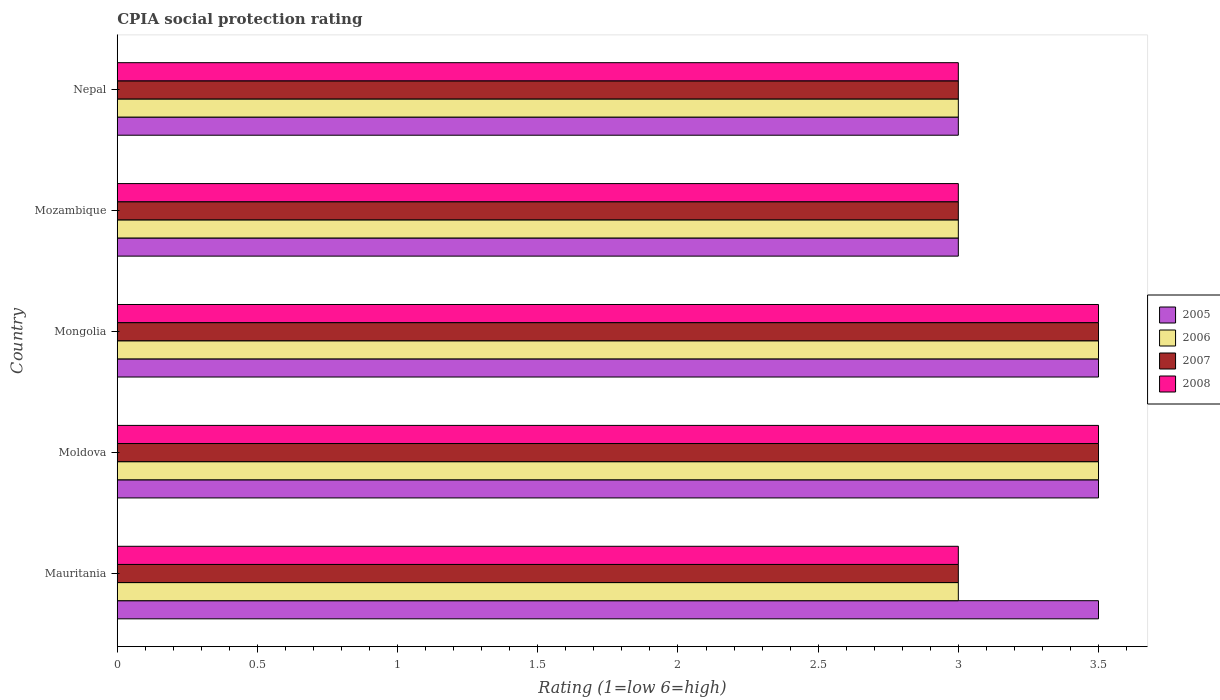How many groups of bars are there?
Your answer should be compact. 5. Are the number of bars on each tick of the Y-axis equal?
Your answer should be compact. Yes. What is the label of the 2nd group of bars from the top?
Your response must be concise. Mozambique. In how many cases, is the number of bars for a given country not equal to the number of legend labels?
Keep it short and to the point. 0. What is the CPIA rating in 2007 in Nepal?
Give a very brief answer. 3. Across all countries, what is the maximum CPIA rating in 2006?
Your answer should be very brief. 3.5. In which country was the CPIA rating in 2007 maximum?
Offer a terse response. Moldova. In which country was the CPIA rating in 2008 minimum?
Provide a short and direct response. Mauritania. What is the total CPIA rating in 2008 in the graph?
Your answer should be very brief. 16. What is the difference between the CPIA rating in 2007 in Mozambique and the CPIA rating in 2005 in Moldova?
Your answer should be very brief. -0.5. What is the difference between the CPIA rating in 2006 and CPIA rating in 2005 in Nepal?
Provide a short and direct response. 0. In how many countries, is the CPIA rating in 2008 greater than 1.5 ?
Keep it short and to the point. 5. What is the ratio of the CPIA rating in 2008 in Moldova to that in Mozambique?
Ensure brevity in your answer.  1.17. What is the difference between the highest and the second highest CPIA rating in 2005?
Your answer should be compact. 0. In how many countries, is the CPIA rating in 2006 greater than the average CPIA rating in 2006 taken over all countries?
Your answer should be very brief. 2. Is it the case that in every country, the sum of the CPIA rating in 2007 and CPIA rating in 2008 is greater than the sum of CPIA rating in 2006 and CPIA rating in 2005?
Offer a very short reply. No. What does the 1st bar from the top in Mauritania represents?
Offer a very short reply. 2008. How many countries are there in the graph?
Your response must be concise. 5. Does the graph contain any zero values?
Provide a short and direct response. No. How many legend labels are there?
Provide a succinct answer. 4. What is the title of the graph?
Your answer should be compact. CPIA social protection rating. Does "1982" appear as one of the legend labels in the graph?
Offer a very short reply. No. What is the label or title of the X-axis?
Your response must be concise. Rating (1=low 6=high). What is the label or title of the Y-axis?
Make the answer very short. Country. What is the Rating (1=low 6=high) of 2006 in Mauritania?
Your answer should be very brief. 3. What is the Rating (1=low 6=high) in 2008 in Mauritania?
Your response must be concise. 3. What is the Rating (1=low 6=high) in 2005 in Moldova?
Keep it short and to the point. 3.5. What is the Rating (1=low 6=high) of 2007 in Moldova?
Your response must be concise. 3.5. What is the Rating (1=low 6=high) in 2006 in Mongolia?
Provide a short and direct response. 3.5. What is the Rating (1=low 6=high) of 2007 in Mozambique?
Provide a short and direct response. 3. What is the Rating (1=low 6=high) in 2005 in Nepal?
Ensure brevity in your answer.  3. What is the Rating (1=low 6=high) of 2006 in Nepal?
Your response must be concise. 3. Across all countries, what is the maximum Rating (1=low 6=high) in 2006?
Your response must be concise. 3.5. Across all countries, what is the maximum Rating (1=low 6=high) of 2007?
Keep it short and to the point. 3.5. Across all countries, what is the maximum Rating (1=low 6=high) in 2008?
Ensure brevity in your answer.  3.5. Across all countries, what is the minimum Rating (1=low 6=high) in 2005?
Your response must be concise. 3. Across all countries, what is the minimum Rating (1=low 6=high) of 2007?
Offer a terse response. 3. Across all countries, what is the minimum Rating (1=low 6=high) of 2008?
Your answer should be compact. 3. What is the total Rating (1=low 6=high) in 2006 in the graph?
Provide a succinct answer. 16. What is the total Rating (1=low 6=high) in 2007 in the graph?
Your response must be concise. 16. What is the total Rating (1=low 6=high) in 2008 in the graph?
Provide a short and direct response. 16. What is the difference between the Rating (1=low 6=high) in 2006 in Mauritania and that in Moldova?
Offer a very short reply. -0.5. What is the difference between the Rating (1=low 6=high) of 2007 in Mauritania and that in Moldova?
Give a very brief answer. -0.5. What is the difference between the Rating (1=low 6=high) of 2006 in Mauritania and that in Mongolia?
Ensure brevity in your answer.  -0.5. What is the difference between the Rating (1=low 6=high) of 2007 in Mauritania and that in Mongolia?
Your answer should be compact. -0.5. What is the difference between the Rating (1=low 6=high) of 2008 in Mauritania and that in Mongolia?
Your answer should be very brief. -0.5. What is the difference between the Rating (1=low 6=high) of 2007 in Mauritania and that in Mozambique?
Offer a terse response. 0. What is the difference between the Rating (1=low 6=high) in 2008 in Mauritania and that in Mozambique?
Offer a very short reply. 0. What is the difference between the Rating (1=low 6=high) in 2007 in Mauritania and that in Nepal?
Your answer should be compact. 0. What is the difference between the Rating (1=low 6=high) in 2007 in Moldova and that in Mongolia?
Provide a short and direct response. 0. What is the difference between the Rating (1=low 6=high) in 2008 in Moldova and that in Mongolia?
Give a very brief answer. 0. What is the difference between the Rating (1=low 6=high) in 2005 in Moldova and that in Mozambique?
Offer a very short reply. 0.5. What is the difference between the Rating (1=low 6=high) of 2006 in Moldova and that in Mozambique?
Ensure brevity in your answer.  0.5. What is the difference between the Rating (1=low 6=high) in 2008 in Moldova and that in Mozambique?
Keep it short and to the point. 0.5. What is the difference between the Rating (1=low 6=high) in 2006 in Moldova and that in Nepal?
Ensure brevity in your answer.  0.5. What is the difference between the Rating (1=low 6=high) of 2008 in Moldova and that in Nepal?
Offer a terse response. 0.5. What is the difference between the Rating (1=low 6=high) of 2006 in Mongolia and that in Mozambique?
Provide a short and direct response. 0.5. What is the difference between the Rating (1=low 6=high) of 2006 in Mongolia and that in Nepal?
Give a very brief answer. 0.5. What is the difference between the Rating (1=low 6=high) of 2008 in Mozambique and that in Nepal?
Provide a short and direct response. 0. What is the difference between the Rating (1=low 6=high) of 2005 in Mauritania and the Rating (1=low 6=high) of 2007 in Moldova?
Provide a short and direct response. 0. What is the difference between the Rating (1=low 6=high) in 2005 in Mauritania and the Rating (1=low 6=high) in 2008 in Moldova?
Give a very brief answer. 0. What is the difference between the Rating (1=low 6=high) of 2006 in Mauritania and the Rating (1=low 6=high) of 2008 in Moldova?
Provide a short and direct response. -0.5. What is the difference between the Rating (1=low 6=high) of 2007 in Mauritania and the Rating (1=low 6=high) of 2008 in Moldova?
Keep it short and to the point. -0.5. What is the difference between the Rating (1=low 6=high) of 2005 in Mauritania and the Rating (1=low 6=high) of 2008 in Mongolia?
Offer a very short reply. 0. What is the difference between the Rating (1=low 6=high) of 2006 in Mauritania and the Rating (1=low 6=high) of 2007 in Mongolia?
Give a very brief answer. -0.5. What is the difference between the Rating (1=low 6=high) of 2007 in Mauritania and the Rating (1=low 6=high) of 2008 in Mongolia?
Offer a terse response. -0.5. What is the difference between the Rating (1=low 6=high) in 2005 in Mauritania and the Rating (1=low 6=high) in 2006 in Mozambique?
Offer a very short reply. 0.5. What is the difference between the Rating (1=low 6=high) of 2005 in Mauritania and the Rating (1=low 6=high) of 2006 in Nepal?
Offer a very short reply. 0.5. What is the difference between the Rating (1=low 6=high) in 2005 in Mauritania and the Rating (1=low 6=high) in 2008 in Nepal?
Ensure brevity in your answer.  0.5. What is the difference between the Rating (1=low 6=high) of 2007 in Mauritania and the Rating (1=low 6=high) of 2008 in Nepal?
Give a very brief answer. 0. What is the difference between the Rating (1=low 6=high) of 2005 in Moldova and the Rating (1=low 6=high) of 2008 in Mozambique?
Ensure brevity in your answer.  0.5. What is the difference between the Rating (1=low 6=high) of 2006 in Moldova and the Rating (1=low 6=high) of 2008 in Mozambique?
Ensure brevity in your answer.  0.5. What is the difference between the Rating (1=low 6=high) of 2005 in Moldova and the Rating (1=low 6=high) of 2007 in Nepal?
Ensure brevity in your answer.  0.5. What is the difference between the Rating (1=low 6=high) in 2006 in Moldova and the Rating (1=low 6=high) in 2007 in Nepal?
Your answer should be very brief. 0.5. What is the difference between the Rating (1=low 6=high) in 2006 in Moldova and the Rating (1=low 6=high) in 2008 in Nepal?
Provide a short and direct response. 0.5. What is the difference between the Rating (1=low 6=high) in 2007 in Moldova and the Rating (1=low 6=high) in 2008 in Nepal?
Give a very brief answer. 0.5. What is the difference between the Rating (1=low 6=high) in 2005 in Mongolia and the Rating (1=low 6=high) in 2006 in Mozambique?
Keep it short and to the point. 0.5. What is the difference between the Rating (1=low 6=high) of 2005 in Mongolia and the Rating (1=low 6=high) of 2007 in Mozambique?
Keep it short and to the point. 0.5. What is the difference between the Rating (1=low 6=high) in 2005 in Mongolia and the Rating (1=low 6=high) in 2006 in Nepal?
Provide a short and direct response. 0.5. What is the difference between the Rating (1=low 6=high) of 2005 in Mongolia and the Rating (1=low 6=high) of 2007 in Nepal?
Make the answer very short. 0.5. What is the difference between the Rating (1=low 6=high) in 2005 in Mongolia and the Rating (1=low 6=high) in 2008 in Nepal?
Offer a very short reply. 0.5. What is the difference between the Rating (1=low 6=high) of 2006 in Mongolia and the Rating (1=low 6=high) of 2007 in Nepal?
Give a very brief answer. 0.5. What is the difference between the Rating (1=low 6=high) in 2007 in Mongolia and the Rating (1=low 6=high) in 2008 in Nepal?
Make the answer very short. 0.5. What is the difference between the Rating (1=low 6=high) in 2005 in Mozambique and the Rating (1=low 6=high) in 2006 in Nepal?
Provide a short and direct response. 0. What is the difference between the Rating (1=low 6=high) of 2005 in Mozambique and the Rating (1=low 6=high) of 2007 in Nepal?
Provide a succinct answer. 0. What is the difference between the Rating (1=low 6=high) in 2005 in Mozambique and the Rating (1=low 6=high) in 2008 in Nepal?
Provide a short and direct response. 0. What is the difference between the Rating (1=low 6=high) of 2006 in Mozambique and the Rating (1=low 6=high) of 2007 in Nepal?
Ensure brevity in your answer.  0. What is the difference between the Rating (1=low 6=high) in 2007 in Mozambique and the Rating (1=low 6=high) in 2008 in Nepal?
Make the answer very short. 0. What is the average Rating (1=low 6=high) of 2005 per country?
Provide a short and direct response. 3.3. What is the average Rating (1=low 6=high) in 2006 per country?
Ensure brevity in your answer.  3.2. What is the average Rating (1=low 6=high) of 2008 per country?
Your answer should be very brief. 3.2. What is the difference between the Rating (1=low 6=high) of 2005 and Rating (1=low 6=high) of 2007 in Mauritania?
Your response must be concise. 0.5. What is the difference between the Rating (1=low 6=high) of 2005 and Rating (1=low 6=high) of 2008 in Mauritania?
Make the answer very short. 0.5. What is the difference between the Rating (1=low 6=high) of 2005 and Rating (1=low 6=high) of 2006 in Moldova?
Offer a terse response. 0. What is the difference between the Rating (1=low 6=high) of 2005 and Rating (1=low 6=high) of 2007 in Moldova?
Offer a very short reply. 0. What is the difference between the Rating (1=low 6=high) of 2005 and Rating (1=low 6=high) of 2008 in Moldova?
Provide a succinct answer. 0. What is the difference between the Rating (1=low 6=high) of 2006 and Rating (1=low 6=high) of 2008 in Mongolia?
Keep it short and to the point. 0. What is the difference between the Rating (1=low 6=high) of 2005 and Rating (1=low 6=high) of 2006 in Mozambique?
Provide a succinct answer. 0. What is the difference between the Rating (1=low 6=high) of 2005 and Rating (1=low 6=high) of 2007 in Mozambique?
Provide a short and direct response. 0. What is the difference between the Rating (1=low 6=high) in 2005 and Rating (1=low 6=high) in 2008 in Mozambique?
Ensure brevity in your answer.  0. What is the difference between the Rating (1=low 6=high) in 2007 and Rating (1=low 6=high) in 2008 in Mozambique?
Provide a succinct answer. 0. What is the difference between the Rating (1=low 6=high) of 2005 and Rating (1=low 6=high) of 2006 in Nepal?
Your answer should be compact. 0. What is the difference between the Rating (1=low 6=high) in 2005 and Rating (1=low 6=high) in 2007 in Nepal?
Provide a short and direct response. 0. What is the difference between the Rating (1=low 6=high) of 2006 and Rating (1=low 6=high) of 2007 in Nepal?
Give a very brief answer. 0. What is the ratio of the Rating (1=low 6=high) in 2007 in Mauritania to that in Mongolia?
Your answer should be very brief. 0.86. What is the ratio of the Rating (1=low 6=high) of 2008 in Mauritania to that in Mongolia?
Give a very brief answer. 0.86. What is the ratio of the Rating (1=low 6=high) in 2005 in Mauritania to that in Mozambique?
Make the answer very short. 1.17. What is the ratio of the Rating (1=low 6=high) of 2006 in Mauritania to that in Mozambique?
Your answer should be very brief. 1. What is the ratio of the Rating (1=low 6=high) in 2008 in Mauritania to that in Mozambique?
Provide a succinct answer. 1. What is the ratio of the Rating (1=low 6=high) of 2005 in Mauritania to that in Nepal?
Ensure brevity in your answer.  1.17. What is the ratio of the Rating (1=low 6=high) in 2006 in Mauritania to that in Nepal?
Your answer should be compact. 1. What is the ratio of the Rating (1=low 6=high) of 2005 in Moldova to that in Mongolia?
Ensure brevity in your answer.  1. What is the ratio of the Rating (1=low 6=high) of 2006 in Moldova to that in Nepal?
Provide a short and direct response. 1.17. What is the ratio of the Rating (1=low 6=high) in 2007 in Moldova to that in Nepal?
Give a very brief answer. 1.17. What is the ratio of the Rating (1=low 6=high) in 2008 in Moldova to that in Nepal?
Offer a very short reply. 1.17. What is the ratio of the Rating (1=low 6=high) in 2005 in Mongolia to that in Mozambique?
Your answer should be compact. 1.17. What is the ratio of the Rating (1=low 6=high) in 2006 in Mongolia to that in Mozambique?
Offer a very short reply. 1.17. What is the ratio of the Rating (1=low 6=high) of 2007 in Mongolia to that in Mozambique?
Your answer should be very brief. 1.17. What is the ratio of the Rating (1=low 6=high) in 2008 in Mongolia to that in Mozambique?
Your answer should be compact. 1.17. What is the ratio of the Rating (1=low 6=high) of 2007 in Mongolia to that in Nepal?
Give a very brief answer. 1.17. What is the ratio of the Rating (1=low 6=high) of 2008 in Mongolia to that in Nepal?
Your answer should be very brief. 1.17. What is the ratio of the Rating (1=low 6=high) in 2005 in Mozambique to that in Nepal?
Your response must be concise. 1. What is the ratio of the Rating (1=low 6=high) in 2007 in Mozambique to that in Nepal?
Your response must be concise. 1. What is the difference between the highest and the second highest Rating (1=low 6=high) of 2005?
Ensure brevity in your answer.  0. What is the difference between the highest and the second highest Rating (1=low 6=high) of 2008?
Ensure brevity in your answer.  0. What is the difference between the highest and the lowest Rating (1=low 6=high) in 2008?
Provide a succinct answer. 0.5. 